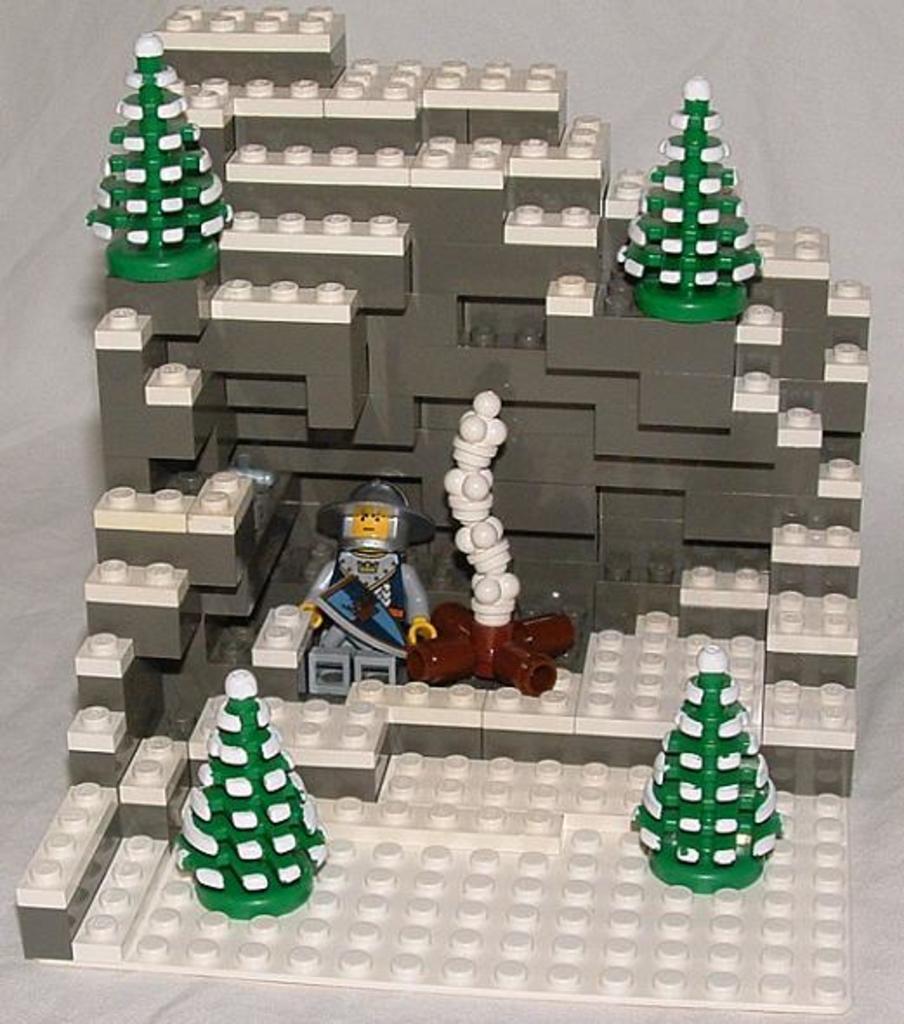How would you summarize this image in a sentence or two? In this image we can see a building made with lego blocks. 